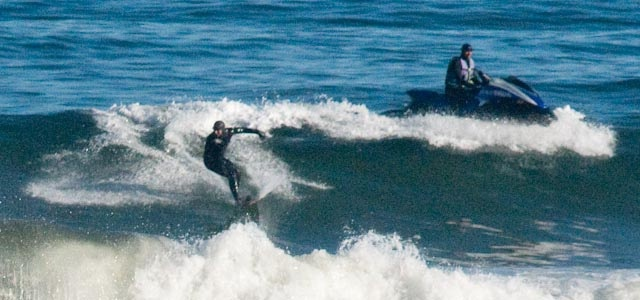Describe the objects in this image and their specific colors. I can see people in gray, navy, darkblue, and blue tones, people in gray, black, navy, and darkgray tones, and surfboard in gray, lightgray, and darkgray tones in this image. 